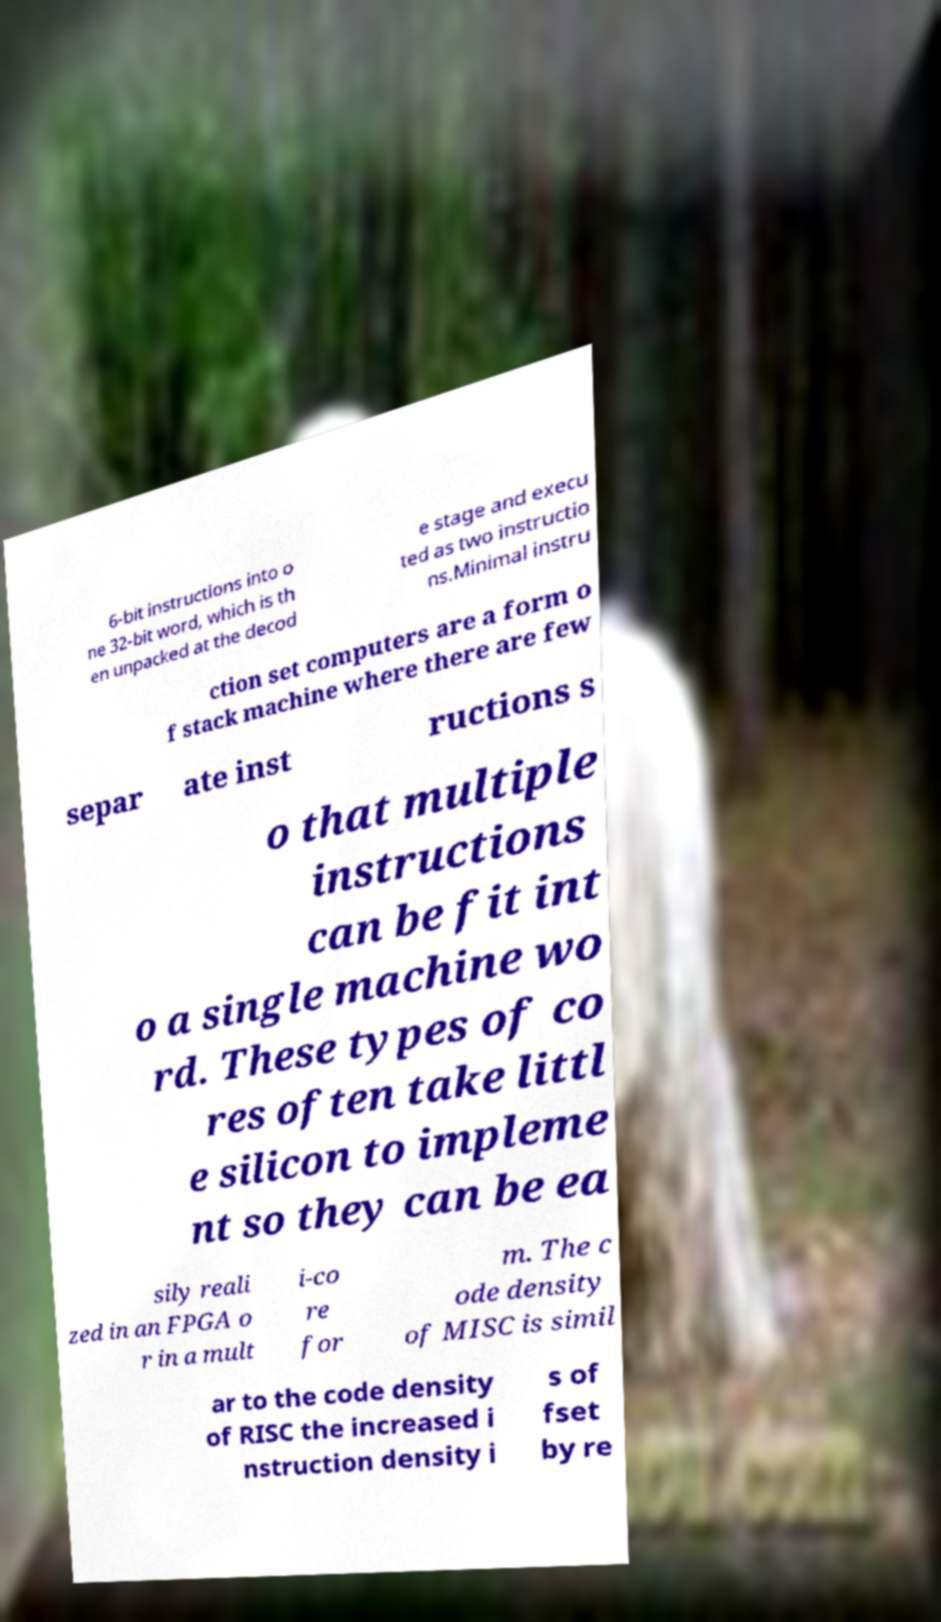I need the written content from this picture converted into text. Can you do that? 6-bit instructions into o ne 32-bit word, which is th en unpacked at the decod e stage and execu ted as two instructio ns.Minimal instru ction set computers are a form o f stack machine where there are few separ ate inst ructions s o that multiple instructions can be fit int o a single machine wo rd. These types of co res often take littl e silicon to impleme nt so they can be ea sily reali zed in an FPGA o r in a mult i-co re for m. The c ode density of MISC is simil ar to the code density of RISC the increased i nstruction density i s of fset by re 